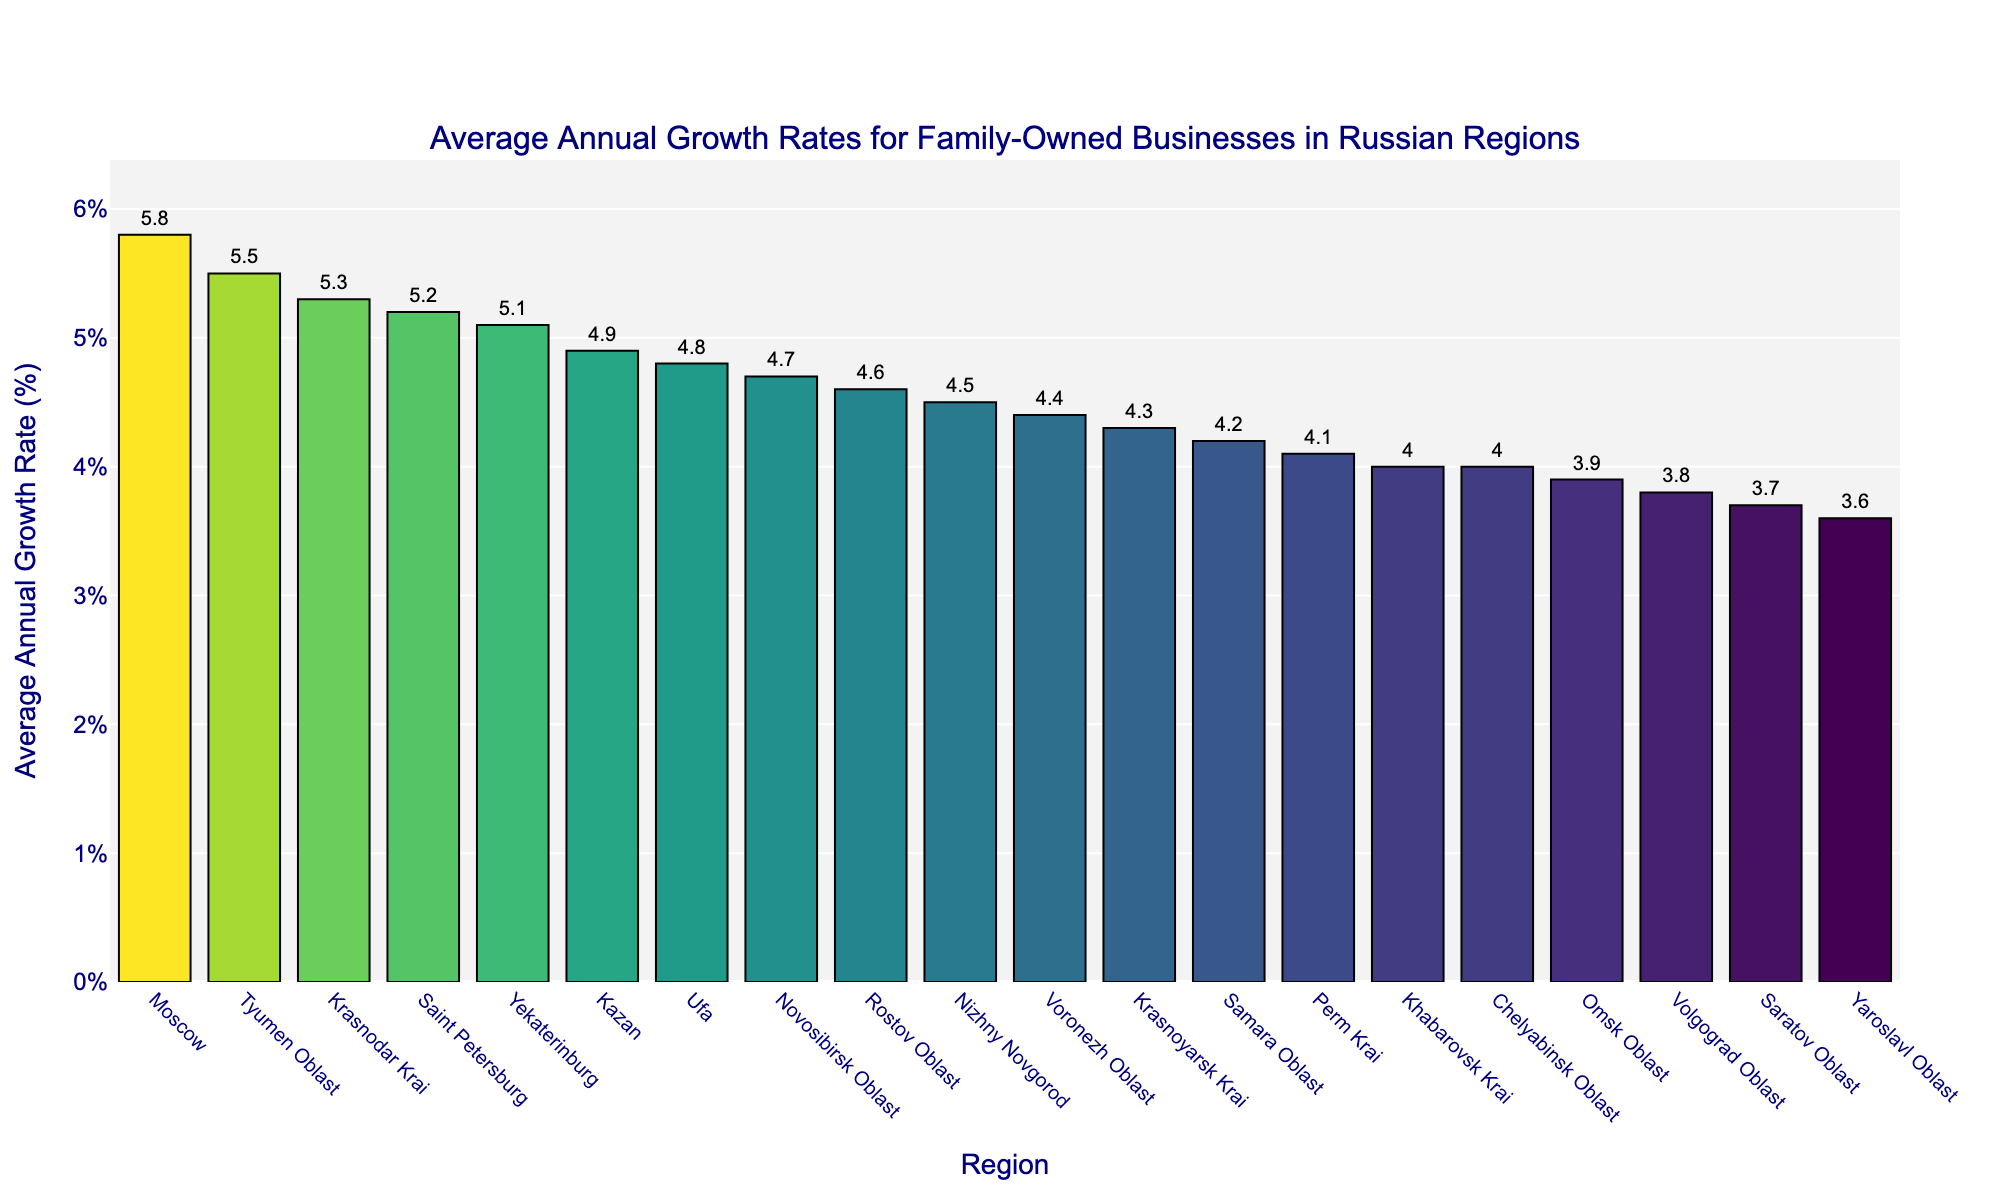What region has the highest average annual growth rate? The tallest bar on the plot, which stands for Moscow, represents the highest average annual growth rate.
Answer: Moscow Which regions have an average annual growth rate greater than 5%? The bars representing Moscow, Saint Petersburg, Yekaterinburg, Krasnodar Krai, and Tyumen Oblast are all above the 5% growth rate mark.
Answer: Moscow, Saint Petersburg, Yekaterinburg, Krasnodar Krai, Tyumen Oblast What is the difference in average annual growth rate between Moscow and Volgograd Oblast? Moscow's growth rate is at 5.8%, while Volgograd Oblast's is at 3.8%. The difference therefore is 5.8% - 3.8% = 2.0%.
Answer: 2.0% Which region has the lowest average annual growth rate and what is it? The shortest bar on the plot is for Yaroslavl Oblast, which has the lowest growth rate.
Answer: Yaroslavl Oblast, 3.6% What is the combined average annual growth rate for the top three regions? The top three regions by growth rate are Moscow (5.8%), Tyumen Oblast (5.5%), and Krasnodar Krai (5.3%). The combined growth rate is 5.8 + 5.5 + 5.3 = 16.6%.
Answer: 16.6% How many regions have an average annual growth rate less than 4%? By counting the bars that fall below the 4% line, we find that Omsk Oblast, Volgograd Oblast, Saratov Oblast, and Yaroslavl Oblast all have growth rates less than 4%. That makes 4 regions in total.
Answer: 4 Does Rostov Oblast have a higher or lower growth rate compared to Voronezh Oblast? Comparing the height of the bars, Rostov Oblast (4.6%) has a higher growth rate than Voronezh Oblast (4.4%).
Answer: Higher What is the average growth rate across all regions shown in the chart? The sum of all displayed growth rates is 84.0%, and since there are 20 regions, the average can be computed as 84.0% / 20 = 4.2%.
Answer: 4.2% Which regions have growth rates between 4% and 5%? The bars for Novosibirsk Oblast (4.7%), Kazan (4.9%), Nizhny Novgorod (4.5%), Krasnoyarsk Krai (4.3%), Rostov Oblast (4.6%), Samara Oblast (4.2%), Voronezh Oblast (4.4%), Perm Krai (4.1%), Ufa (4.8%), Khabarovsk Krai (4.0%) fall within this range.
Answer: Novosibirsk Oblast, Kazan, Nizhny Novgorod, Krasnoyarsk Krai, Rostov Oblast, Samara Oblast, Voronezh Oblast, Perm Krai, Ufa, Khabarovsk Krai What is unique about the color and height of the bar for Tyumen Oblast? The bar for Tyumen Oblast, being darker and relatively high on the chart, is colored this way because it represents one of the highest growth rates at 5.5%.
Answer: Darker color and relatively high height 